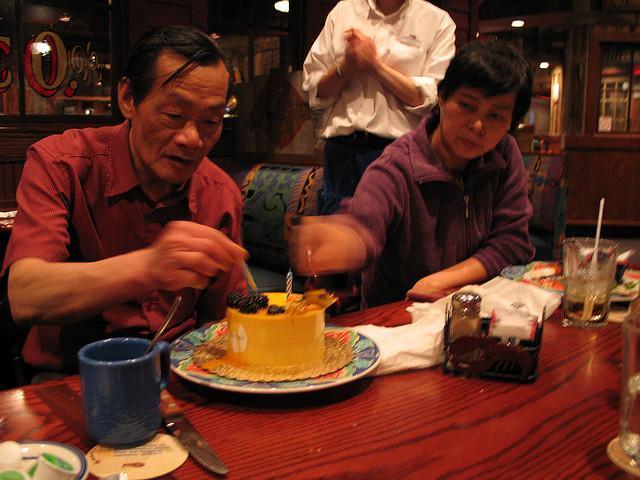How many candles?
Give a very brief answer. 3. How many cups are in the photo?
Give a very brief answer. 3. How many people are in the photo?
Give a very brief answer. 3. 